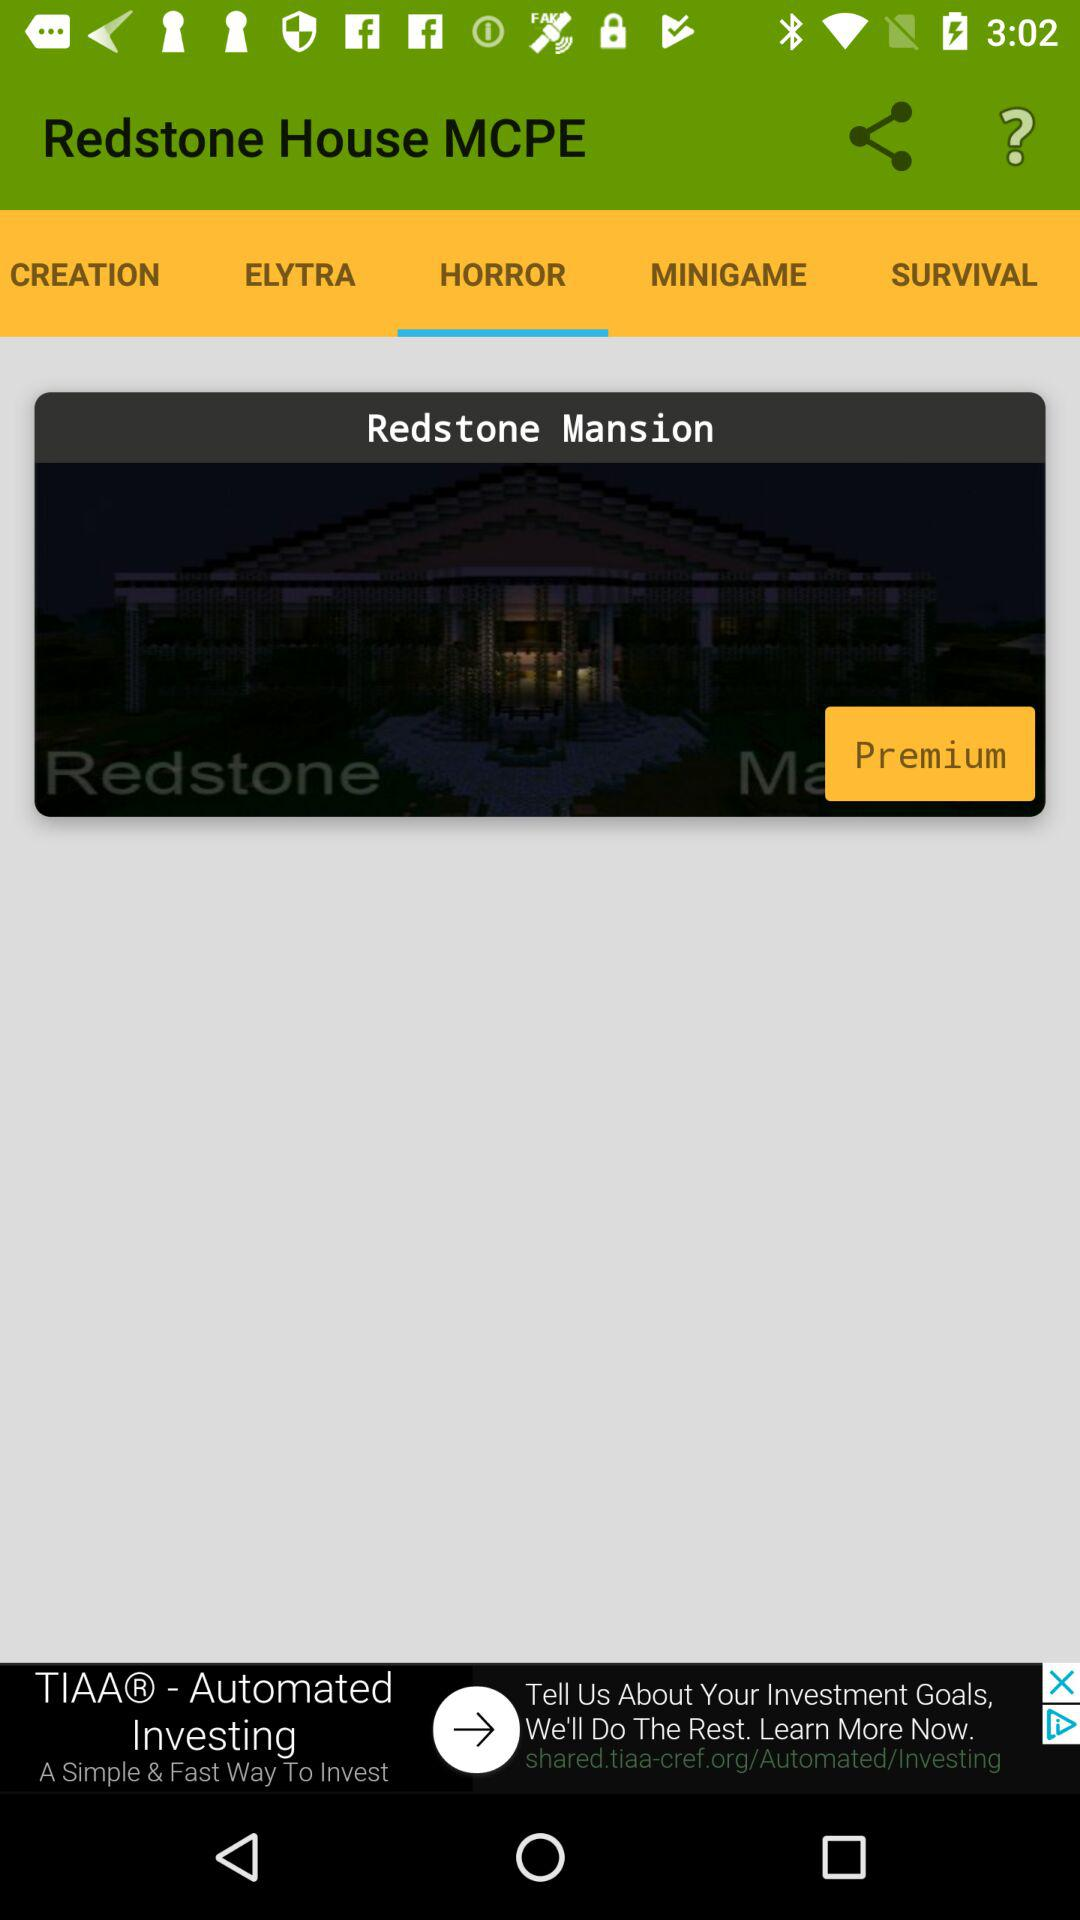What is the application name? The application name is "Redstone House MCPE". 